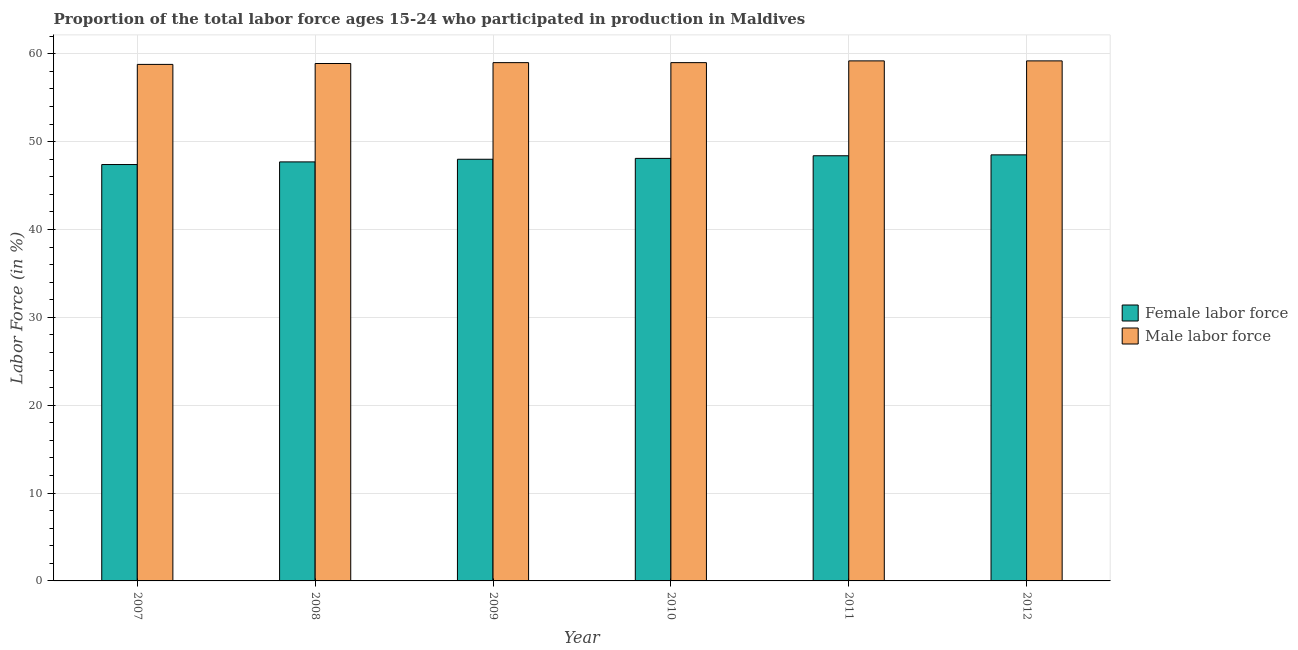How many different coloured bars are there?
Offer a very short reply. 2. Are the number of bars on each tick of the X-axis equal?
Give a very brief answer. Yes. What is the label of the 6th group of bars from the left?
Your answer should be compact. 2012. In how many cases, is the number of bars for a given year not equal to the number of legend labels?
Make the answer very short. 0. What is the percentage of male labour force in 2009?
Your response must be concise. 59. Across all years, what is the maximum percentage of female labor force?
Your response must be concise. 48.5. Across all years, what is the minimum percentage of male labour force?
Your response must be concise. 58.8. In which year was the percentage of male labour force minimum?
Give a very brief answer. 2007. What is the total percentage of male labour force in the graph?
Keep it short and to the point. 354.1. What is the difference between the percentage of female labor force in 2008 and the percentage of male labour force in 2009?
Provide a succinct answer. -0.3. What is the average percentage of male labour force per year?
Offer a terse response. 59.02. In the year 2007, what is the difference between the percentage of female labor force and percentage of male labour force?
Your answer should be compact. 0. What is the ratio of the percentage of female labor force in 2007 to that in 2009?
Keep it short and to the point. 0.99. What is the difference between the highest and the second highest percentage of male labour force?
Your answer should be compact. 0. What is the difference between the highest and the lowest percentage of female labor force?
Ensure brevity in your answer.  1.1. In how many years, is the percentage of female labor force greater than the average percentage of female labor force taken over all years?
Your answer should be compact. 3. Is the sum of the percentage of male labour force in 2010 and 2012 greater than the maximum percentage of female labor force across all years?
Provide a short and direct response. Yes. What does the 1st bar from the left in 2008 represents?
Make the answer very short. Female labor force. What does the 2nd bar from the right in 2012 represents?
Keep it short and to the point. Female labor force. How many bars are there?
Offer a very short reply. 12. Are all the bars in the graph horizontal?
Provide a short and direct response. No. Are the values on the major ticks of Y-axis written in scientific E-notation?
Offer a very short reply. No. Does the graph contain any zero values?
Give a very brief answer. No. Does the graph contain grids?
Offer a terse response. Yes. How are the legend labels stacked?
Offer a very short reply. Vertical. What is the title of the graph?
Keep it short and to the point. Proportion of the total labor force ages 15-24 who participated in production in Maldives. What is the label or title of the X-axis?
Give a very brief answer. Year. What is the Labor Force (in %) of Female labor force in 2007?
Your answer should be very brief. 47.4. What is the Labor Force (in %) of Male labor force in 2007?
Your answer should be compact. 58.8. What is the Labor Force (in %) of Female labor force in 2008?
Offer a terse response. 47.7. What is the Labor Force (in %) in Male labor force in 2008?
Provide a succinct answer. 58.9. What is the Labor Force (in %) in Female labor force in 2009?
Keep it short and to the point. 48. What is the Labor Force (in %) in Female labor force in 2010?
Make the answer very short. 48.1. What is the Labor Force (in %) of Female labor force in 2011?
Ensure brevity in your answer.  48.4. What is the Labor Force (in %) in Male labor force in 2011?
Give a very brief answer. 59.2. What is the Labor Force (in %) of Female labor force in 2012?
Provide a succinct answer. 48.5. What is the Labor Force (in %) in Male labor force in 2012?
Offer a very short reply. 59.2. Across all years, what is the maximum Labor Force (in %) in Female labor force?
Offer a terse response. 48.5. Across all years, what is the maximum Labor Force (in %) of Male labor force?
Provide a succinct answer. 59.2. Across all years, what is the minimum Labor Force (in %) in Female labor force?
Give a very brief answer. 47.4. Across all years, what is the minimum Labor Force (in %) in Male labor force?
Your answer should be compact. 58.8. What is the total Labor Force (in %) of Female labor force in the graph?
Offer a terse response. 288.1. What is the total Labor Force (in %) of Male labor force in the graph?
Offer a very short reply. 354.1. What is the difference between the Labor Force (in %) of Female labor force in 2007 and that in 2008?
Offer a very short reply. -0.3. What is the difference between the Labor Force (in %) of Female labor force in 2007 and that in 2009?
Give a very brief answer. -0.6. What is the difference between the Labor Force (in %) of Male labor force in 2007 and that in 2012?
Offer a very short reply. -0.4. What is the difference between the Labor Force (in %) of Female labor force in 2008 and that in 2009?
Offer a very short reply. -0.3. What is the difference between the Labor Force (in %) of Male labor force in 2008 and that in 2009?
Make the answer very short. -0.1. What is the difference between the Labor Force (in %) of Female labor force in 2008 and that in 2011?
Your answer should be compact. -0.7. What is the difference between the Labor Force (in %) of Male labor force in 2008 and that in 2012?
Give a very brief answer. -0.3. What is the difference between the Labor Force (in %) of Female labor force in 2009 and that in 2010?
Your answer should be very brief. -0.1. What is the difference between the Labor Force (in %) of Male labor force in 2009 and that in 2010?
Your answer should be compact. 0. What is the difference between the Labor Force (in %) of Female labor force in 2009 and that in 2011?
Give a very brief answer. -0.4. What is the difference between the Labor Force (in %) of Male labor force in 2009 and that in 2012?
Your answer should be very brief. -0.2. What is the difference between the Labor Force (in %) of Female labor force in 2010 and that in 2012?
Offer a very short reply. -0.4. What is the difference between the Labor Force (in %) in Male labor force in 2010 and that in 2012?
Keep it short and to the point. -0.2. What is the difference between the Labor Force (in %) of Male labor force in 2011 and that in 2012?
Keep it short and to the point. 0. What is the difference between the Labor Force (in %) of Female labor force in 2007 and the Labor Force (in %) of Male labor force in 2009?
Provide a succinct answer. -11.6. What is the difference between the Labor Force (in %) in Female labor force in 2007 and the Labor Force (in %) in Male labor force in 2011?
Provide a short and direct response. -11.8. What is the difference between the Labor Force (in %) in Female labor force in 2009 and the Labor Force (in %) in Male labor force in 2011?
Keep it short and to the point. -11.2. What is the difference between the Labor Force (in %) in Female labor force in 2009 and the Labor Force (in %) in Male labor force in 2012?
Offer a very short reply. -11.2. What is the difference between the Labor Force (in %) in Female labor force in 2010 and the Labor Force (in %) in Male labor force in 2011?
Offer a very short reply. -11.1. What is the difference between the Labor Force (in %) of Female labor force in 2011 and the Labor Force (in %) of Male labor force in 2012?
Your answer should be very brief. -10.8. What is the average Labor Force (in %) in Female labor force per year?
Offer a terse response. 48.02. What is the average Labor Force (in %) in Male labor force per year?
Give a very brief answer. 59.02. In the year 2008, what is the difference between the Labor Force (in %) in Female labor force and Labor Force (in %) in Male labor force?
Make the answer very short. -11.2. What is the ratio of the Labor Force (in %) of Female labor force in 2007 to that in 2009?
Ensure brevity in your answer.  0.99. What is the ratio of the Labor Force (in %) in Female labor force in 2007 to that in 2010?
Offer a very short reply. 0.99. What is the ratio of the Labor Force (in %) of Male labor force in 2007 to that in 2010?
Provide a succinct answer. 1. What is the ratio of the Labor Force (in %) of Female labor force in 2007 to that in 2011?
Your answer should be compact. 0.98. What is the ratio of the Labor Force (in %) in Male labor force in 2007 to that in 2011?
Offer a terse response. 0.99. What is the ratio of the Labor Force (in %) in Female labor force in 2007 to that in 2012?
Your answer should be very brief. 0.98. What is the ratio of the Labor Force (in %) of Male labor force in 2007 to that in 2012?
Ensure brevity in your answer.  0.99. What is the ratio of the Labor Force (in %) in Male labor force in 2008 to that in 2010?
Make the answer very short. 1. What is the ratio of the Labor Force (in %) in Female labor force in 2008 to that in 2011?
Provide a short and direct response. 0.99. What is the ratio of the Labor Force (in %) in Male labor force in 2008 to that in 2011?
Ensure brevity in your answer.  0.99. What is the ratio of the Labor Force (in %) of Female labor force in 2008 to that in 2012?
Offer a terse response. 0.98. What is the ratio of the Labor Force (in %) of Male labor force in 2008 to that in 2012?
Offer a very short reply. 0.99. What is the ratio of the Labor Force (in %) in Male labor force in 2009 to that in 2010?
Provide a succinct answer. 1. What is the ratio of the Labor Force (in %) in Female labor force in 2009 to that in 2012?
Provide a short and direct response. 0.99. What is the ratio of the Labor Force (in %) in Female labor force in 2010 to that in 2012?
Keep it short and to the point. 0.99. What is the ratio of the Labor Force (in %) in Male labor force in 2010 to that in 2012?
Make the answer very short. 1. What is the ratio of the Labor Force (in %) in Female labor force in 2011 to that in 2012?
Offer a very short reply. 1. What is the difference between the highest and the second highest Labor Force (in %) of Female labor force?
Provide a short and direct response. 0.1. What is the difference between the highest and the second highest Labor Force (in %) in Male labor force?
Your response must be concise. 0. What is the difference between the highest and the lowest Labor Force (in %) in Female labor force?
Your response must be concise. 1.1. 